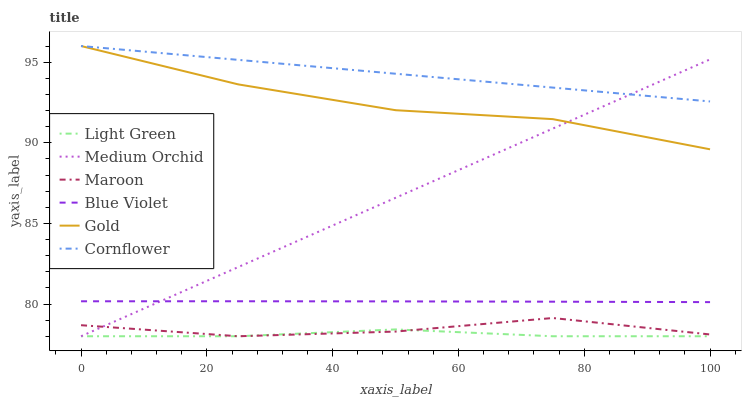Does Light Green have the minimum area under the curve?
Answer yes or no. Yes. Does Cornflower have the maximum area under the curve?
Answer yes or no. Yes. Does Gold have the minimum area under the curve?
Answer yes or no. No. Does Gold have the maximum area under the curve?
Answer yes or no. No. Is Cornflower the smoothest?
Answer yes or no. Yes. Is Maroon the roughest?
Answer yes or no. Yes. Is Gold the smoothest?
Answer yes or no. No. Is Gold the roughest?
Answer yes or no. No. Does Medium Orchid have the lowest value?
Answer yes or no. Yes. Does Gold have the lowest value?
Answer yes or no. No. Does Gold have the highest value?
Answer yes or no. Yes. Does Medium Orchid have the highest value?
Answer yes or no. No. Is Maroon less than Blue Violet?
Answer yes or no. Yes. Is Cornflower greater than Maroon?
Answer yes or no. Yes. Does Light Green intersect Maroon?
Answer yes or no. Yes. Is Light Green less than Maroon?
Answer yes or no. No. Is Light Green greater than Maroon?
Answer yes or no. No. Does Maroon intersect Blue Violet?
Answer yes or no. No. 